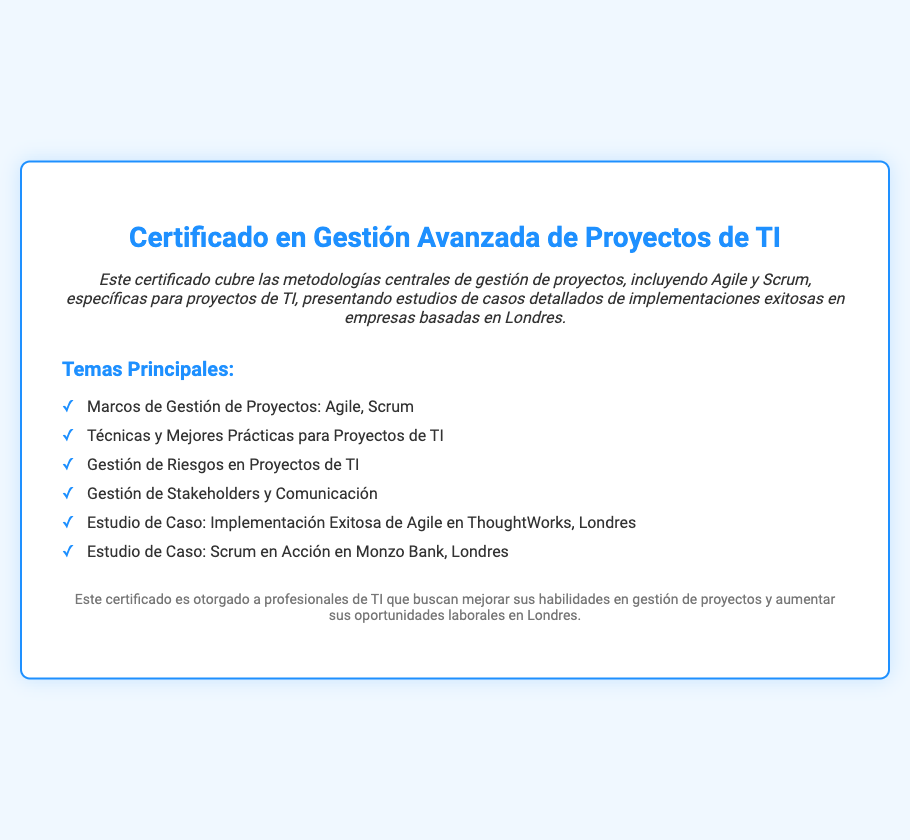¿Qué cubre el certificado? El certificado cubre las metodologías centrales de gestión de proyectos, incluyendo Agile y Scrum, específicas para proyectos de TI.
Answer: Metodologías centrales de gestión de proyectos, incluyendo Agile y Scrum ¿Cuántos estudios de caso se presentan? El documento menciona dos estudios de caso sobre implementaciones exitosas en empresas en Londres.
Answer: Dos ¿Quién es una de las empresas mencionadas en los estudios de caso? La descripción incluye estudios de caso de implementaciones exitosas en ThoughtWorks y Monzo Bank, ambas basadas en Londres.
Answer: ThoughtWorks ¿Qué técnica de gestión se destaca en el certificado? El documento menciona la gestión de riesgos como una de las técnicas aplicadas en proyectos de TI.
Answer: Gestión de Riesgos ¿Cuál es el objetivo del certificado? El objetivo es mejorar las habilidades en gestión de proyectos y aumentar oportunidades laborales en Londres.
Answer: Mejorar habilidades en gestión de proyectos ¿A quién está dirigido este certificado? Se menciona que el certificado es otorgado a profesionales de TI.
Answer: Profesionales de TI ¿Qué metodología se aplica en un estudio de caso específico? Se destaca la implementación de la metodología Scrum en el caso de estudio relacionado con Monzo Bank.
Answer: Scrum ¿Qué tipo de comunicación se menciona como importante en la gestión de proyectos? En el documento se menciona la gestión de stakeholders y comunicación como un aspecto crucial.
Answer: Gestión de Stakeholders y Comunicación 